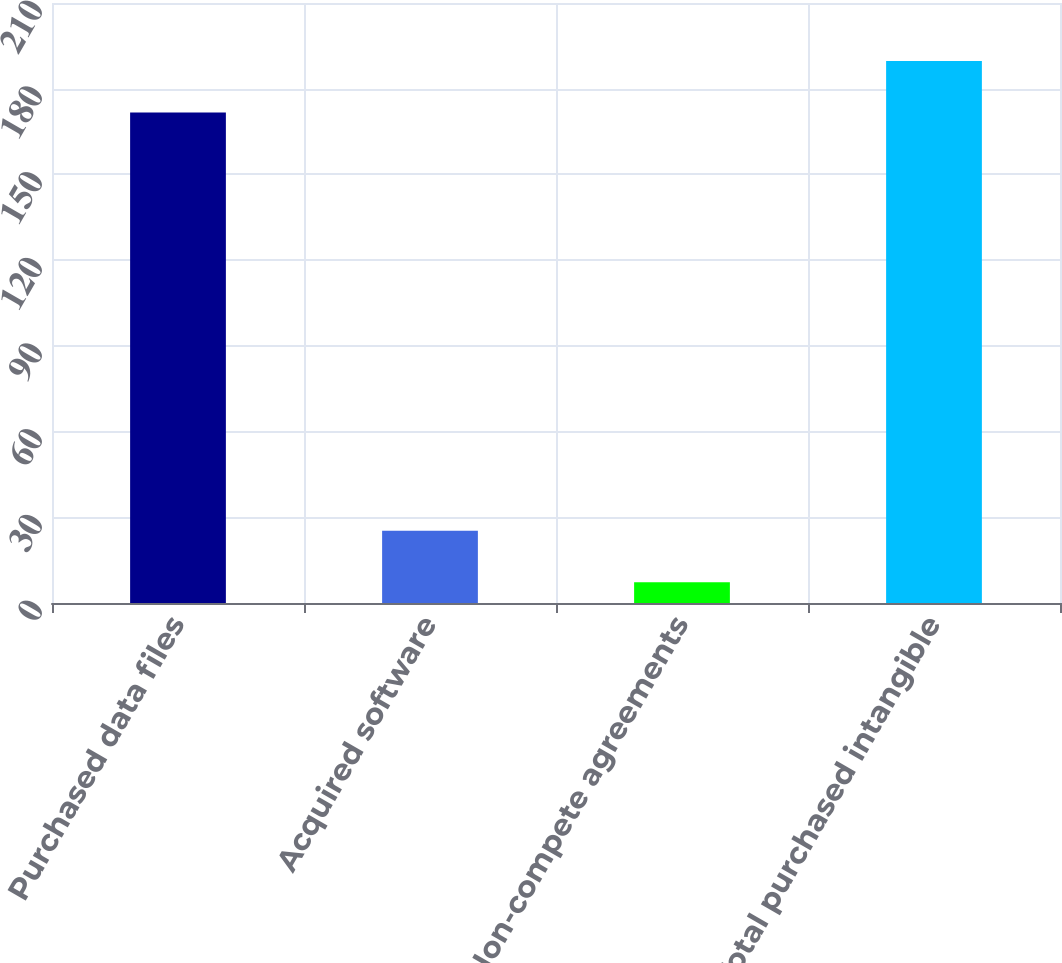<chart> <loc_0><loc_0><loc_500><loc_500><bar_chart><fcel>Purchased data files<fcel>Acquired software<fcel>Non-compete agreements<fcel>Total purchased intangible<nl><fcel>171.7<fcel>25.29<fcel>7.3<fcel>189.69<nl></chart> 